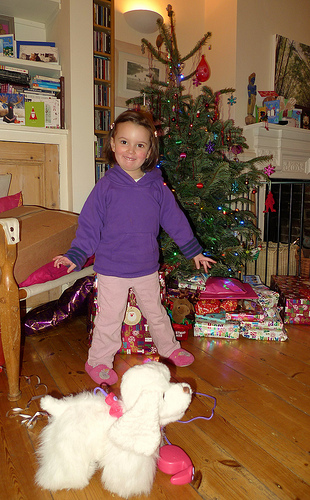<image>
Is there a girl under the tree? No. The girl is not positioned under the tree. The vertical relationship between these objects is different. 